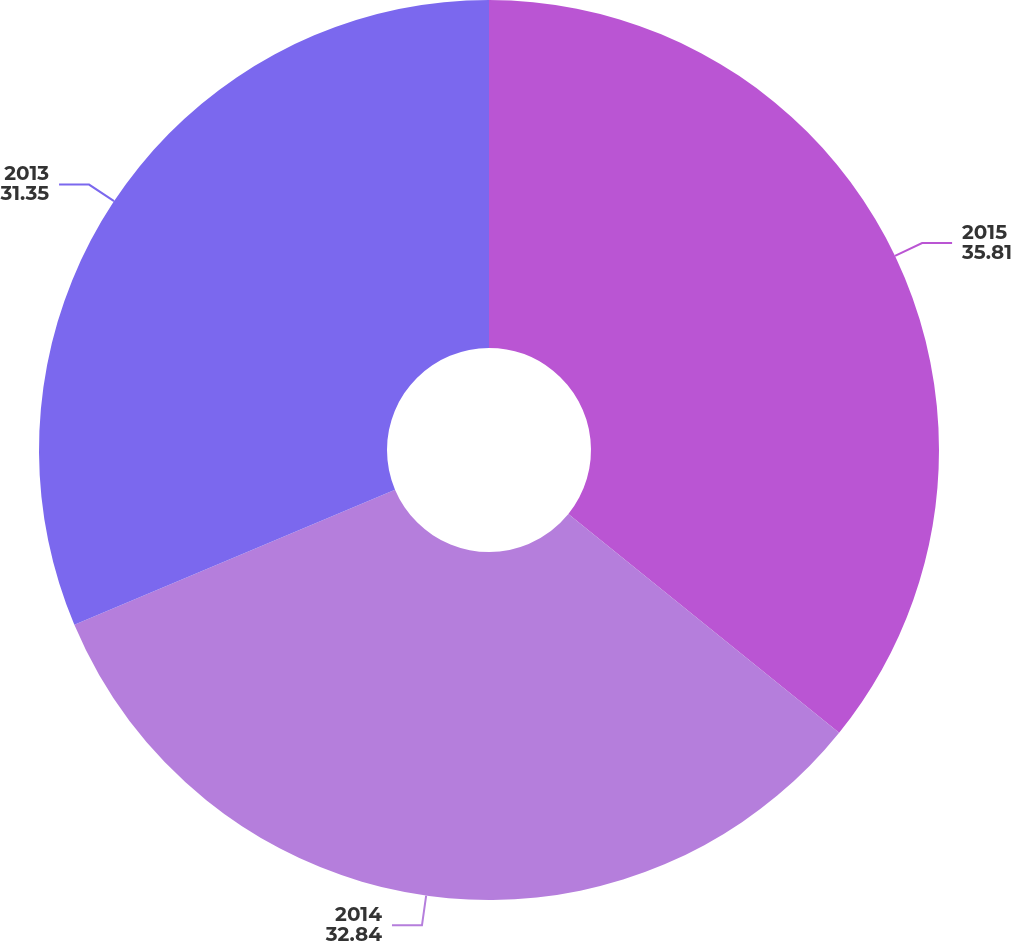<chart> <loc_0><loc_0><loc_500><loc_500><pie_chart><fcel>2015<fcel>2014<fcel>2013<nl><fcel>35.81%<fcel>32.84%<fcel>31.35%<nl></chart> 